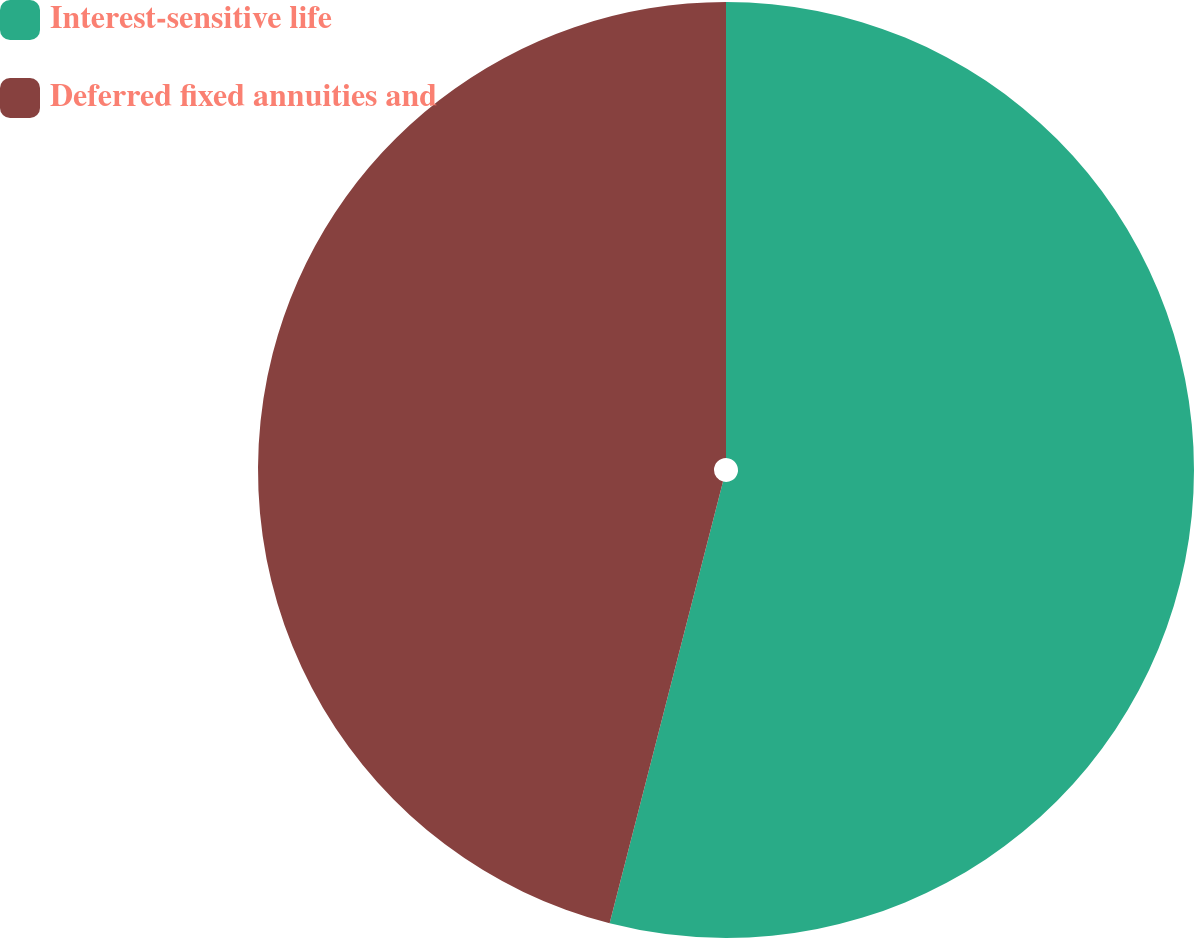<chart> <loc_0><loc_0><loc_500><loc_500><pie_chart><fcel>Interest-sensitive life<fcel>Deferred fixed annuities and<nl><fcel>54.0%<fcel>46.0%<nl></chart> 